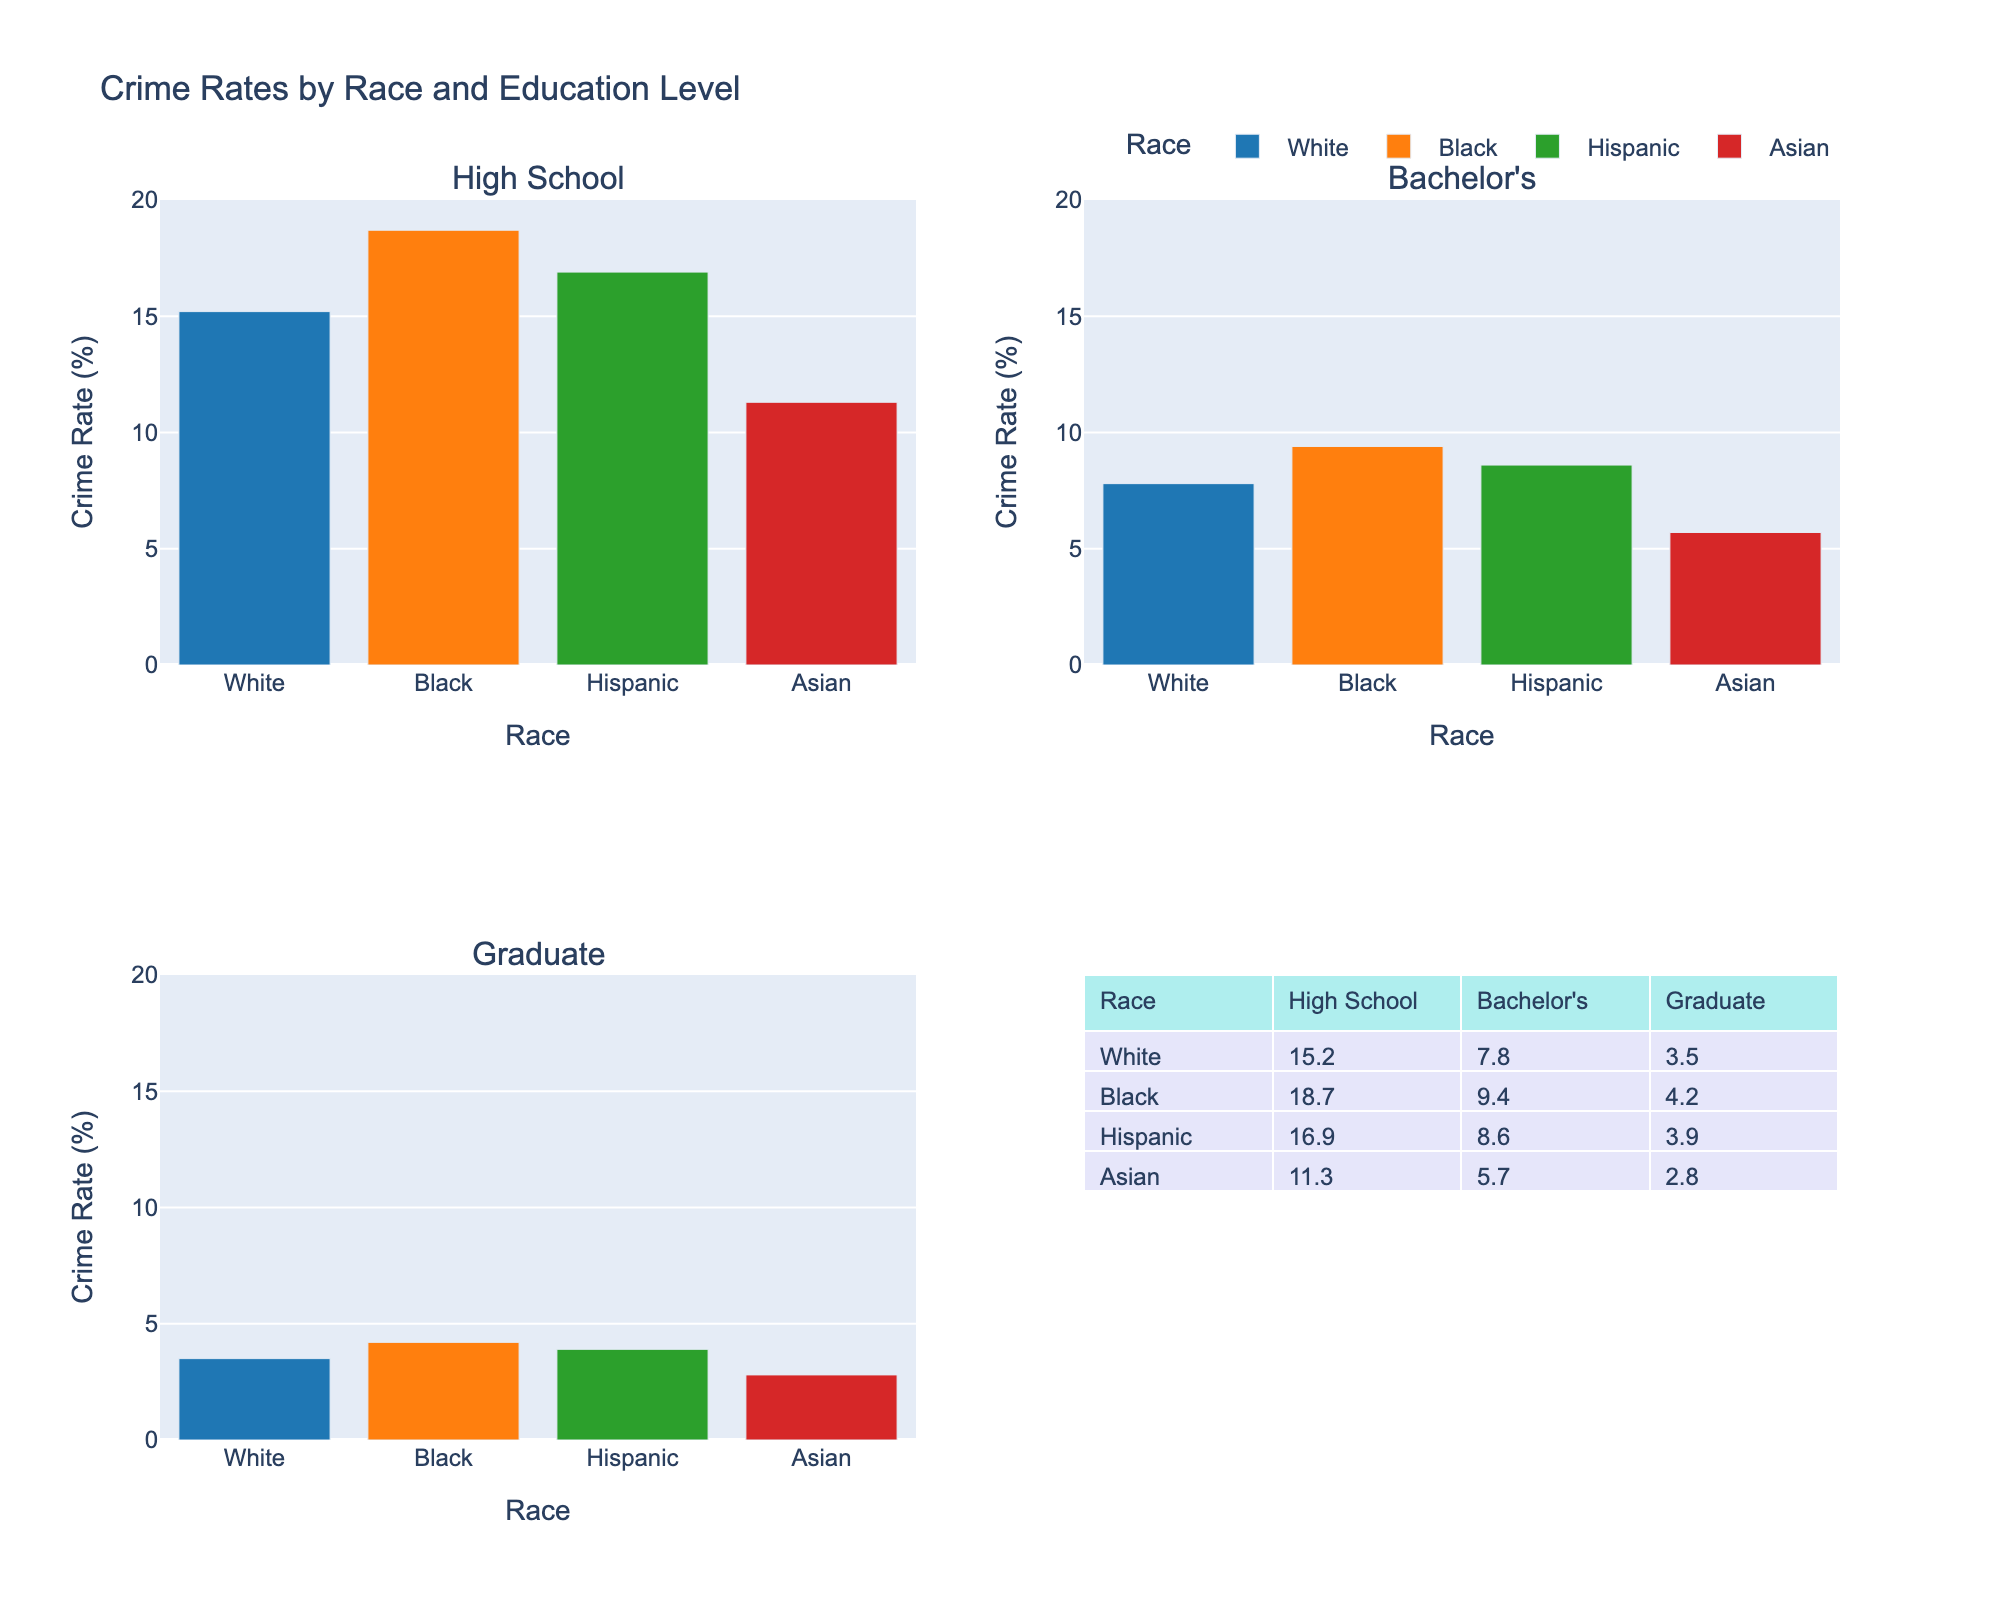What is the title of the chart? The title is displayed at the top of the chart, and it reads "Crime Rates by Race and Education Level."
Answer: Crime Rates by Race and Education Level How many races are compared in the chart? Each bar in the subplots represents one of the races, which totals four: White, Black, Hispanic, and Asian.
Answer: Four What is the crime rate for Blacks with a Bachelor's degree? In the subplot labeled "Bachelor's," locate the bar for Blacks and read the crime rate value from the y-axis, which is 9.4%.
Answer: 9.4% Which race has the lowest crime rate among those with a Graduate degree? In the subplot labeled "Graduate," compare the bars and find that Asians have the lowest crime rate at 2.8%.
Answer: Asians How does the crime rate for Hispanics with a High School education compare to those with a Bachelor's? Locate the Hispanic bars in the "High School" and "Bachelor's" subplots, note the values (16.9 and 8.6), and compare them. The crime rate for Hispanics with a Bachelor's is lower.
Answer: Lower What is the average crime rate across all races for those with a Graduate degree? Average the crime rates for all races in the "Graduate" subplot: (3.5 + 4.2 + 3.9 + 2.8) / 4. The sum is 14.4; divide by 4 to get 3.6%.
Answer: 3.6% What is the total crime rate percentage for Asians across all education levels? Sum the crime rates for Asians in all three subplots: (11.3 + 5.7 + 2.8). The total is 19.8%.
Answer: 19.8% Which educational level shows the most significant difference in crime rates between Whites and Blacks? Calculate the differences for each educational level: 
- High School: 18.7 - 15.2 = 3.5
- Bachelor's: 9.4 - 7.8 = 1.6
- Graduate: 4.2 - 3.5 = 0.7
The highest difference is at the High School level.
Answer: High School Which race sees the largest reduction in crime rate when moving from High School to Bachelor's? For each race, subtract the Bachelor's crime rate from the High School rate and find the largest difference:
- White: 15.2 - 7.8 = 7.4
- Black: 18.7 - 9.4 = 9.3
- Hispanic: 16.9 - 8.6 = 8.3
- Asian: 11.3 - 5.7 = 5.6
Blacks see the largest reduction of 9.3%.
Answer: Blacks 